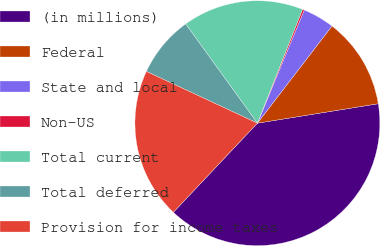<chart> <loc_0><loc_0><loc_500><loc_500><pie_chart><fcel>(in millions)<fcel>Federal<fcel>State and local<fcel>Non-US<fcel>Total current<fcel>Total deferred<fcel>Provision for income taxes<nl><fcel>39.57%<fcel>12.04%<fcel>4.17%<fcel>0.24%<fcel>15.97%<fcel>8.1%<fcel>19.91%<nl></chart> 